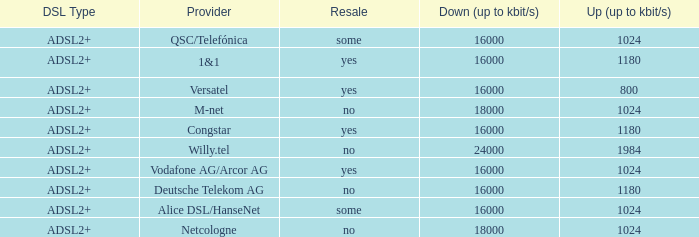What is the resale category for the provider NetCologne? No. 